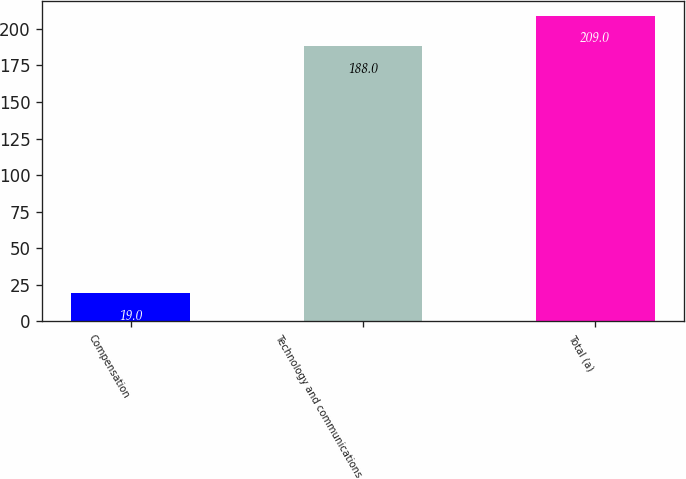Convert chart. <chart><loc_0><loc_0><loc_500><loc_500><bar_chart><fcel>Compensation<fcel>Technology and communications<fcel>Total (a)<nl><fcel>19<fcel>188<fcel>209<nl></chart> 